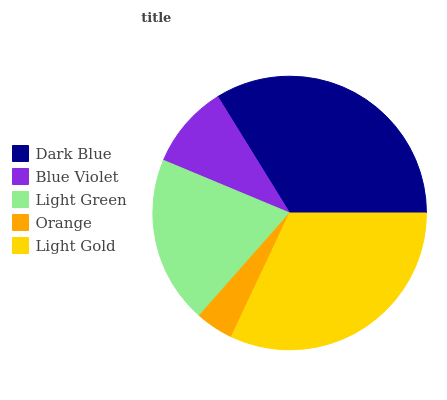Is Orange the minimum?
Answer yes or no. Yes. Is Dark Blue the maximum?
Answer yes or no. Yes. Is Blue Violet the minimum?
Answer yes or no. No. Is Blue Violet the maximum?
Answer yes or no. No. Is Dark Blue greater than Blue Violet?
Answer yes or no. Yes. Is Blue Violet less than Dark Blue?
Answer yes or no. Yes. Is Blue Violet greater than Dark Blue?
Answer yes or no. No. Is Dark Blue less than Blue Violet?
Answer yes or no. No. Is Light Green the high median?
Answer yes or no. Yes. Is Light Green the low median?
Answer yes or no. Yes. Is Blue Violet the high median?
Answer yes or no. No. Is Orange the low median?
Answer yes or no. No. 